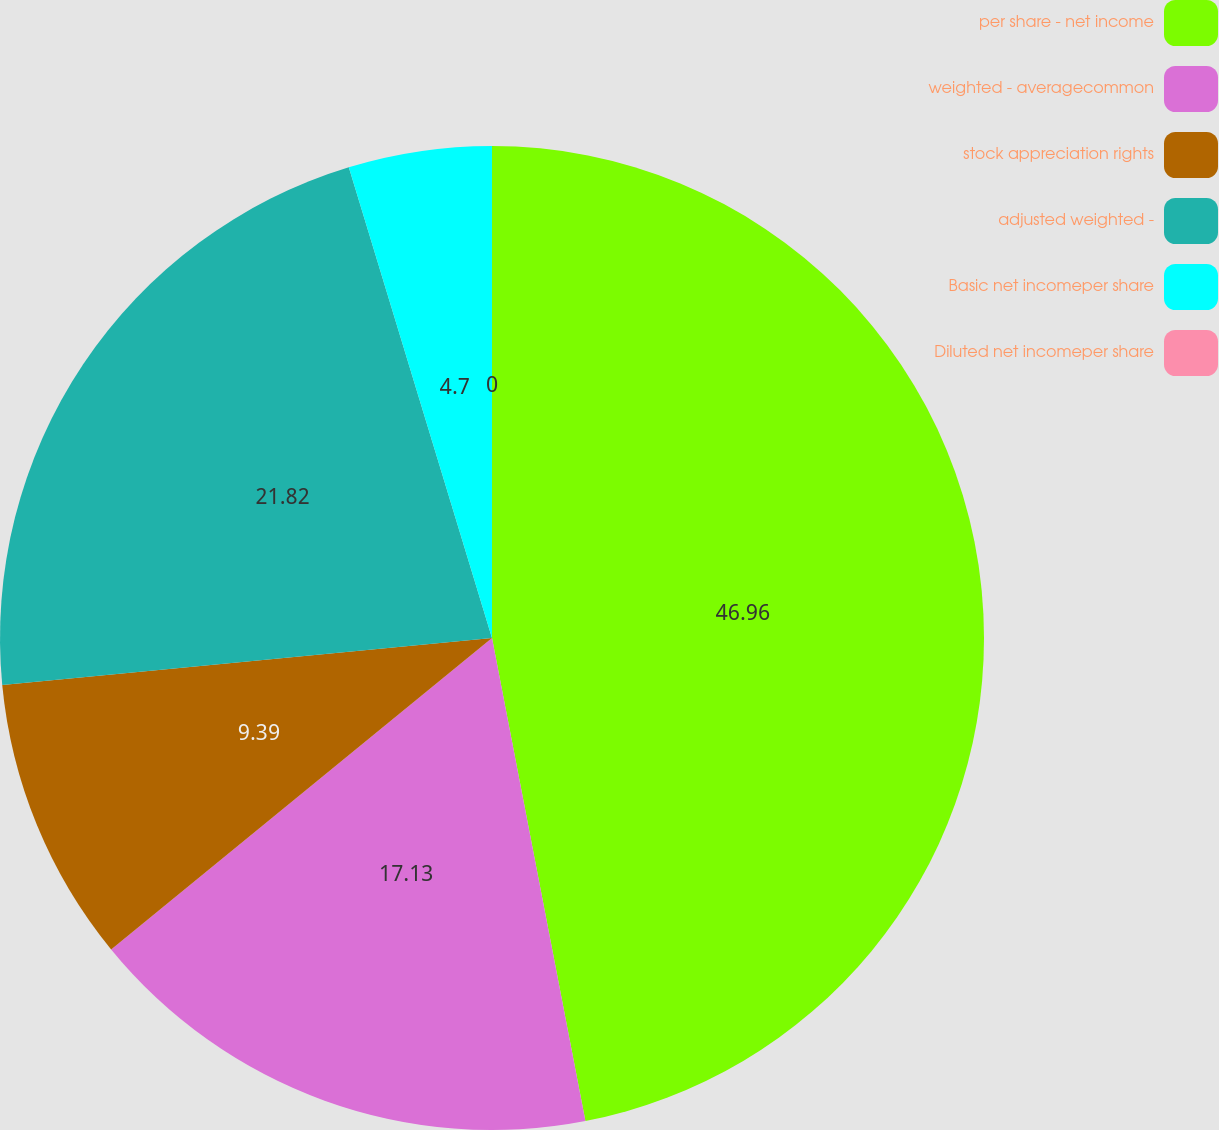Convert chart to OTSL. <chart><loc_0><loc_0><loc_500><loc_500><pie_chart><fcel>per share - net income<fcel>weighted - averagecommon<fcel>stock appreciation rights<fcel>adjusted weighted -<fcel>Basic net incomeper share<fcel>Diluted net incomeper share<nl><fcel>46.96%<fcel>17.13%<fcel>9.39%<fcel>21.82%<fcel>4.7%<fcel>0.0%<nl></chart> 